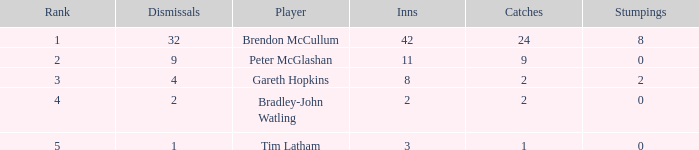Would you be able to parse every entry in this table? {'header': ['Rank', 'Dismissals', 'Player', 'Inns', 'Catches', 'Stumpings'], 'rows': [['1', '32', 'Brendon McCullum', '42', '24', '8'], ['2', '9', 'Peter McGlashan', '11', '9', '0'], ['3', '4', 'Gareth Hopkins', '8', '2', '2'], ['4', '2', 'Bradley-John Watling', '2', '2', '0'], ['5', '1', 'Tim Latham', '3', '1', '0']]} How many stumpings did the player Tim Latham have? 0.0. 